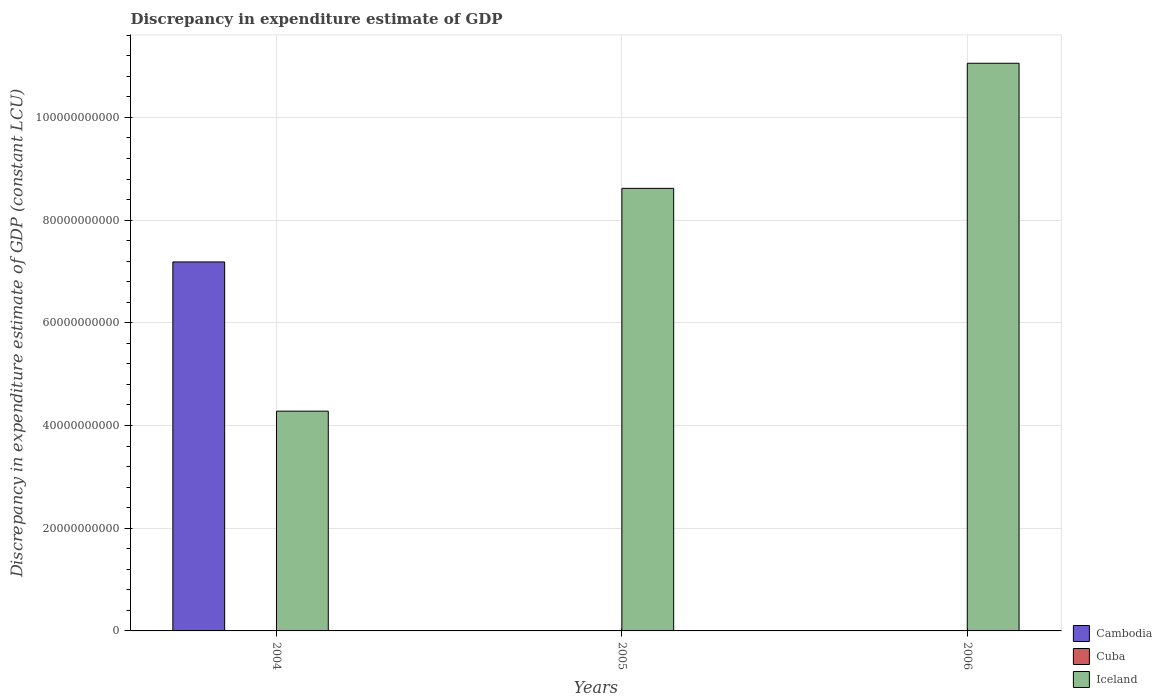How many different coloured bars are there?
Give a very brief answer. 3. How many groups of bars are there?
Your response must be concise. 3. Are the number of bars on each tick of the X-axis equal?
Your answer should be compact. Yes. How many bars are there on the 3rd tick from the left?
Make the answer very short. 2. How many bars are there on the 2nd tick from the right?
Your response must be concise. 2. What is the label of the 1st group of bars from the left?
Offer a very short reply. 2004. In how many cases, is the number of bars for a given year not equal to the number of legend labels?
Give a very brief answer. 3. What is the discrepancy in expenditure estimate of GDP in Iceland in 2004?
Your answer should be very brief. 4.28e+1. Across all years, what is the maximum discrepancy in expenditure estimate of GDP in Iceland?
Your answer should be compact. 1.11e+11. Across all years, what is the minimum discrepancy in expenditure estimate of GDP in Iceland?
Keep it short and to the point. 4.28e+1. In which year was the discrepancy in expenditure estimate of GDP in Iceland maximum?
Your response must be concise. 2006. What is the total discrepancy in expenditure estimate of GDP in Iceland in the graph?
Provide a short and direct response. 2.40e+11. What is the difference between the discrepancy in expenditure estimate of GDP in Iceland in 2004 and that in 2005?
Provide a short and direct response. -4.34e+1. What is the difference between the discrepancy in expenditure estimate of GDP in Iceland in 2005 and the discrepancy in expenditure estimate of GDP in Cambodia in 2004?
Your answer should be compact. 1.43e+1. What is the average discrepancy in expenditure estimate of GDP in Cuba per year?
Offer a very short reply. 2.66e+07. In the year 2006, what is the difference between the discrepancy in expenditure estimate of GDP in Cuba and discrepancy in expenditure estimate of GDP in Iceland?
Your answer should be compact. -1.10e+11. What is the ratio of the discrepancy in expenditure estimate of GDP in Iceland in 2004 to that in 2006?
Your answer should be very brief. 0.39. Is the discrepancy in expenditure estimate of GDP in Cuba in 2005 less than that in 2006?
Offer a very short reply. Yes. Is the difference between the discrepancy in expenditure estimate of GDP in Cuba in 2005 and 2006 greater than the difference between the discrepancy in expenditure estimate of GDP in Iceland in 2005 and 2006?
Provide a short and direct response. Yes. What is the difference between the highest and the second highest discrepancy in expenditure estimate of GDP in Iceland?
Your answer should be compact. 2.44e+1. What is the difference between the highest and the lowest discrepancy in expenditure estimate of GDP in Cuba?
Ensure brevity in your answer.  7.89e+07. Are all the bars in the graph horizontal?
Your answer should be compact. No. Are the values on the major ticks of Y-axis written in scientific E-notation?
Make the answer very short. No. What is the title of the graph?
Give a very brief answer. Discrepancy in expenditure estimate of GDP. What is the label or title of the X-axis?
Your response must be concise. Years. What is the label or title of the Y-axis?
Your answer should be compact. Discrepancy in expenditure estimate of GDP (constant LCU). What is the Discrepancy in expenditure estimate of GDP (constant LCU) of Cambodia in 2004?
Your response must be concise. 7.19e+1. What is the Discrepancy in expenditure estimate of GDP (constant LCU) of Iceland in 2004?
Provide a short and direct response. 4.28e+1. What is the Discrepancy in expenditure estimate of GDP (constant LCU) in Cuba in 2005?
Your answer should be compact. 9.00e+05. What is the Discrepancy in expenditure estimate of GDP (constant LCU) of Iceland in 2005?
Ensure brevity in your answer.  8.62e+1. What is the Discrepancy in expenditure estimate of GDP (constant LCU) in Cuba in 2006?
Offer a terse response. 7.89e+07. What is the Discrepancy in expenditure estimate of GDP (constant LCU) of Iceland in 2006?
Ensure brevity in your answer.  1.11e+11. Across all years, what is the maximum Discrepancy in expenditure estimate of GDP (constant LCU) in Cambodia?
Your answer should be very brief. 7.19e+1. Across all years, what is the maximum Discrepancy in expenditure estimate of GDP (constant LCU) of Cuba?
Make the answer very short. 7.89e+07. Across all years, what is the maximum Discrepancy in expenditure estimate of GDP (constant LCU) in Iceland?
Give a very brief answer. 1.11e+11. Across all years, what is the minimum Discrepancy in expenditure estimate of GDP (constant LCU) of Cambodia?
Provide a short and direct response. 0. Across all years, what is the minimum Discrepancy in expenditure estimate of GDP (constant LCU) of Iceland?
Your answer should be very brief. 4.28e+1. What is the total Discrepancy in expenditure estimate of GDP (constant LCU) in Cambodia in the graph?
Keep it short and to the point. 7.19e+1. What is the total Discrepancy in expenditure estimate of GDP (constant LCU) of Cuba in the graph?
Keep it short and to the point. 7.98e+07. What is the total Discrepancy in expenditure estimate of GDP (constant LCU) in Iceland in the graph?
Offer a very short reply. 2.40e+11. What is the difference between the Discrepancy in expenditure estimate of GDP (constant LCU) of Iceland in 2004 and that in 2005?
Your answer should be compact. -4.34e+1. What is the difference between the Discrepancy in expenditure estimate of GDP (constant LCU) of Iceland in 2004 and that in 2006?
Ensure brevity in your answer.  -6.78e+1. What is the difference between the Discrepancy in expenditure estimate of GDP (constant LCU) in Cuba in 2005 and that in 2006?
Give a very brief answer. -7.80e+07. What is the difference between the Discrepancy in expenditure estimate of GDP (constant LCU) of Iceland in 2005 and that in 2006?
Make the answer very short. -2.44e+1. What is the difference between the Discrepancy in expenditure estimate of GDP (constant LCU) of Cambodia in 2004 and the Discrepancy in expenditure estimate of GDP (constant LCU) of Cuba in 2005?
Keep it short and to the point. 7.19e+1. What is the difference between the Discrepancy in expenditure estimate of GDP (constant LCU) of Cambodia in 2004 and the Discrepancy in expenditure estimate of GDP (constant LCU) of Iceland in 2005?
Offer a terse response. -1.43e+1. What is the difference between the Discrepancy in expenditure estimate of GDP (constant LCU) of Cambodia in 2004 and the Discrepancy in expenditure estimate of GDP (constant LCU) of Cuba in 2006?
Ensure brevity in your answer.  7.18e+1. What is the difference between the Discrepancy in expenditure estimate of GDP (constant LCU) of Cambodia in 2004 and the Discrepancy in expenditure estimate of GDP (constant LCU) of Iceland in 2006?
Offer a very short reply. -3.87e+1. What is the difference between the Discrepancy in expenditure estimate of GDP (constant LCU) in Cuba in 2005 and the Discrepancy in expenditure estimate of GDP (constant LCU) in Iceland in 2006?
Provide a short and direct response. -1.11e+11. What is the average Discrepancy in expenditure estimate of GDP (constant LCU) in Cambodia per year?
Make the answer very short. 2.40e+1. What is the average Discrepancy in expenditure estimate of GDP (constant LCU) of Cuba per year?
Give a very brief answer. 2.66e+07. What is the average Discrepancy in expenditure estimate of GDP (constant LCU) in Iceland per year?
Offer a very short reply. 7.98e+1. In the year 2004, what is the difference between the Discrepancy in expenditure estimate of GDP (constant LCU) in Cambodia and Discrepancy in expenditure estimate of GDP (constant LCU) in Iceland?
Offer a terse response. 2.91e+1. In the year 2005, what is the difference between the Discrepancy in expenditure estimate of GDP (constant LCU) of Cuba and Discrepancy in expenditure estimate of GDP (constant LCU) of Iceland?
Your answer should be very brief. -8.62e+1. In the year 2006, what is the difference between the Discrepancy in expenditure estimate of GDP (constant LCU) of Cuba and Discrepancy in expenditure estimate of GDP (constant LCU) of Iceland?
Keep it short and to the point. -1.10e+11. What is the ratio of the Discrepancy in expenditure estimate of GDP (constant LCU) in Iceland in 2004 to that in 2005?
Your answer should be very brief. 0.5. What is the ratio of the Discrepancy in expenditure estimate of GDP (constant LCU) in Iceland in 2004 to that in 2006?
Give a very brief answer. 0.39. What is the ratio of the Discrepancy in expenditure estimate of GDP (constant LCU) in Cuba in 2005 to that in 2006?
Make the answer very short. 0.01. What is the ratio of the Discrepancy in expenditure estimate of GDP (constant LCU) in Iceland in 2005 to that in 2006?
Make the answer very short. 0.78. What is the difference between the highest and the second highest Discrepancy in expenditure estimate of GDP (constant LCU) of Iceland?
Your answer should be compact. 2.44e+1. What is the difference between the highest and the lowest Discrepancy in expenditure estimate of GDP (constant LCU) of Cambodia?
Give a very brief answer. 7.19e+1. What is the difference between the highest and the lowest Discrepancy in expenditure estimate of GDP (constant LCU) in Cuba?
Provide a succinct answer. 7.89e+07. What is the difference between the highest and the lowest Discrepancy in expenditure estimate of GDP (constant LCU) in Iceland?
Provide a short and direct response. 6.78e+1. 